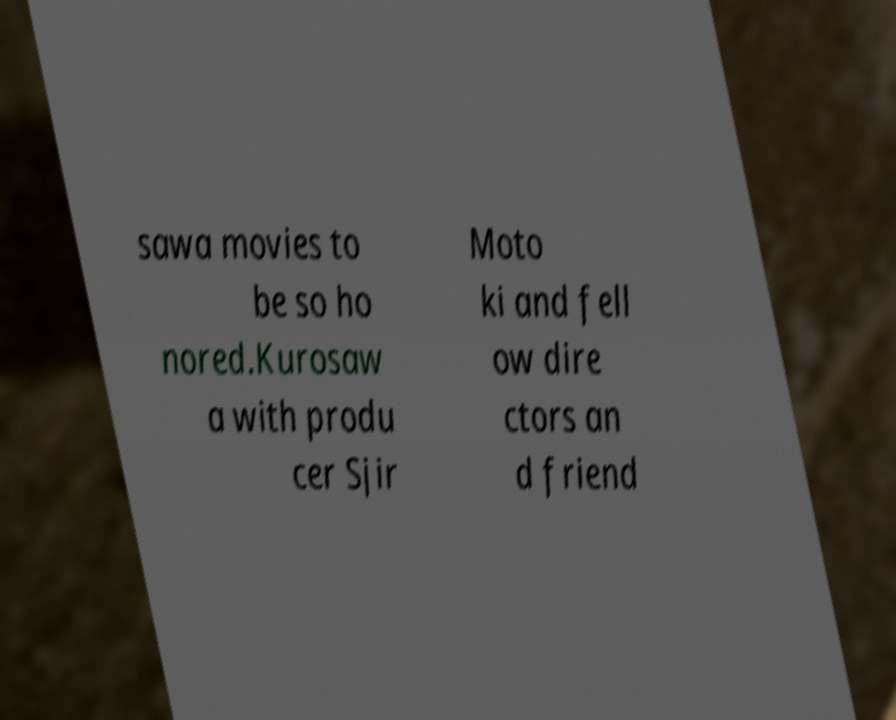For documentation purposes, I need the text within this image transcribed. Could you provide that? sawa movies to be so ho nored.Kurosaw a with produ cer Sjir Moto ki and fell ow dire ctors an d friend 